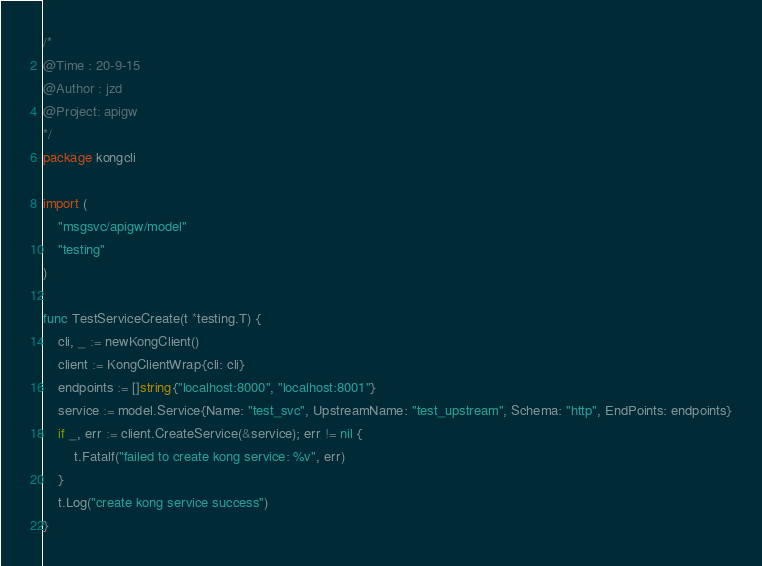<code> <loc_0><loc_0><loc_500><loc_500><_Go_>/*
@Time : 20-9-15
@Author : jzd
@Project: apigw
*/
package kongcli

import (
	"msgsvc/apigw/model"
	"testing"
)

func TestServiceCreate(t *testing.T) {
	cli, _ := newKongClient()
	client := KongClientWrap{cli: cli}
	endpoints := []string{"localhost:8000", "localhost:8001"}
	service := model.Service{Name: "test_svc", UpstreamName: "test_upstream", Schema: "http", EndPoints: endpoints}
	if _, err := client.CreateService(&service); err != nil {
		t.Fatalf("failed to create kong service: %v", err)
	}
	t.Log("create kong service success")
}
</code> 